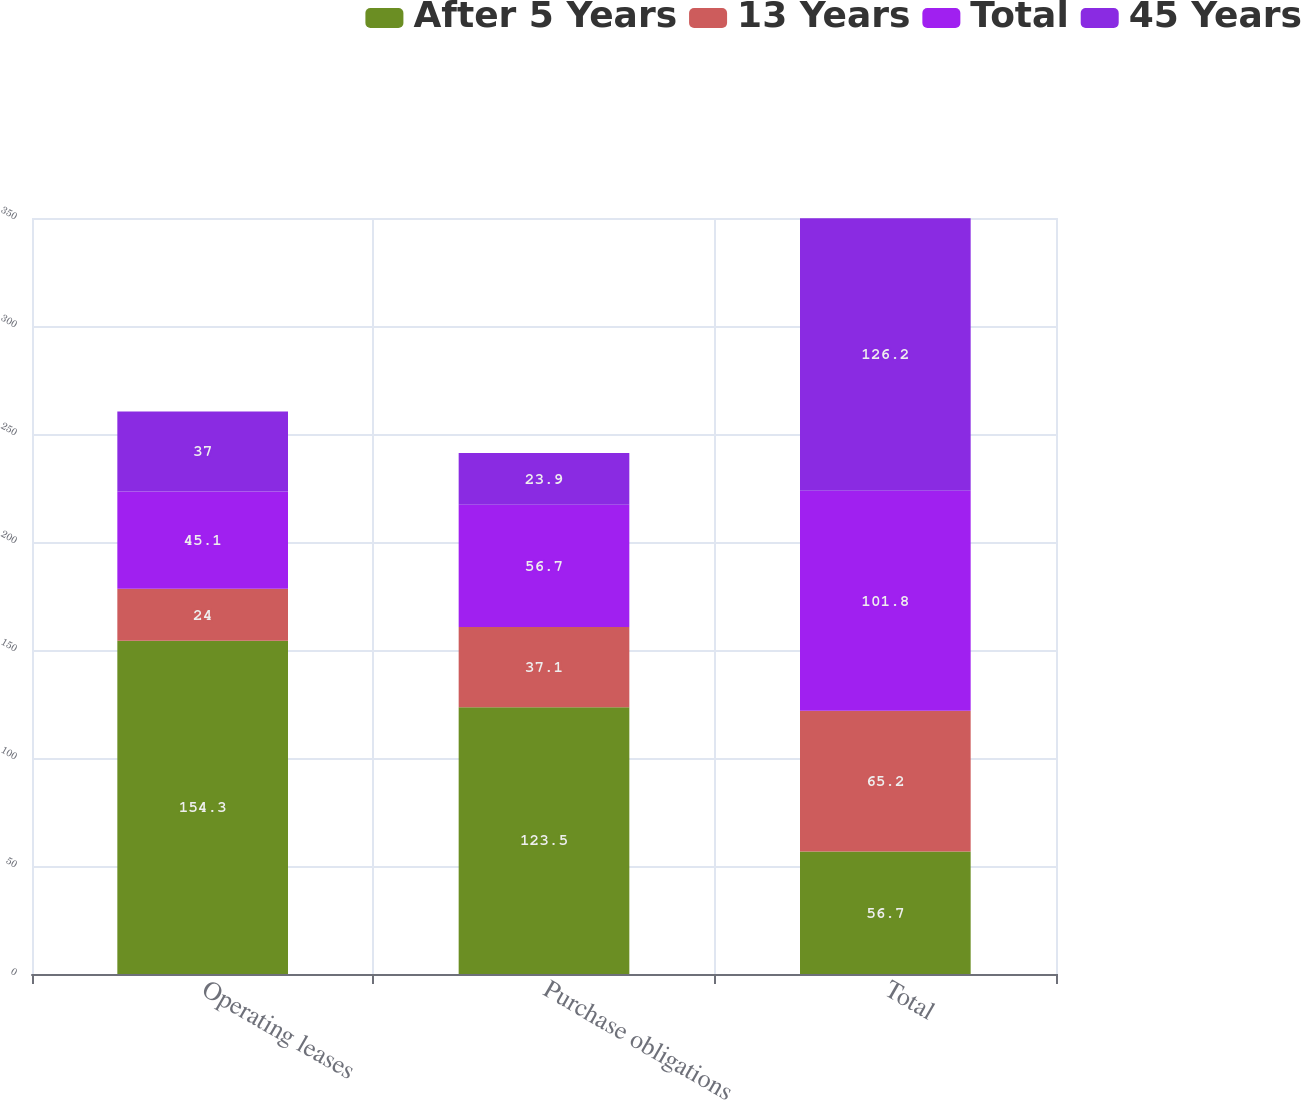Convert chart to OTSL. <chart><loc_0><loc_0><loc_500><loc_500><stacked_bar_chart><ecel><fcel>Operating leases<fcel>Purchase obligations<fcel>Total<nl><fcel>After 5 Years<fcel>154.3<fcel>123.5<fcel>56.7<nl><fcel>13 Years<fcel>24<fcel>37.1<fcel>65.2<nl><fcel>Total<fcel>45.1<fcel>56.7<fcel>101.8<nl><fcel>45 Years<fcel>37<fcel>23.9<fcel>126.2<nl></chart> 